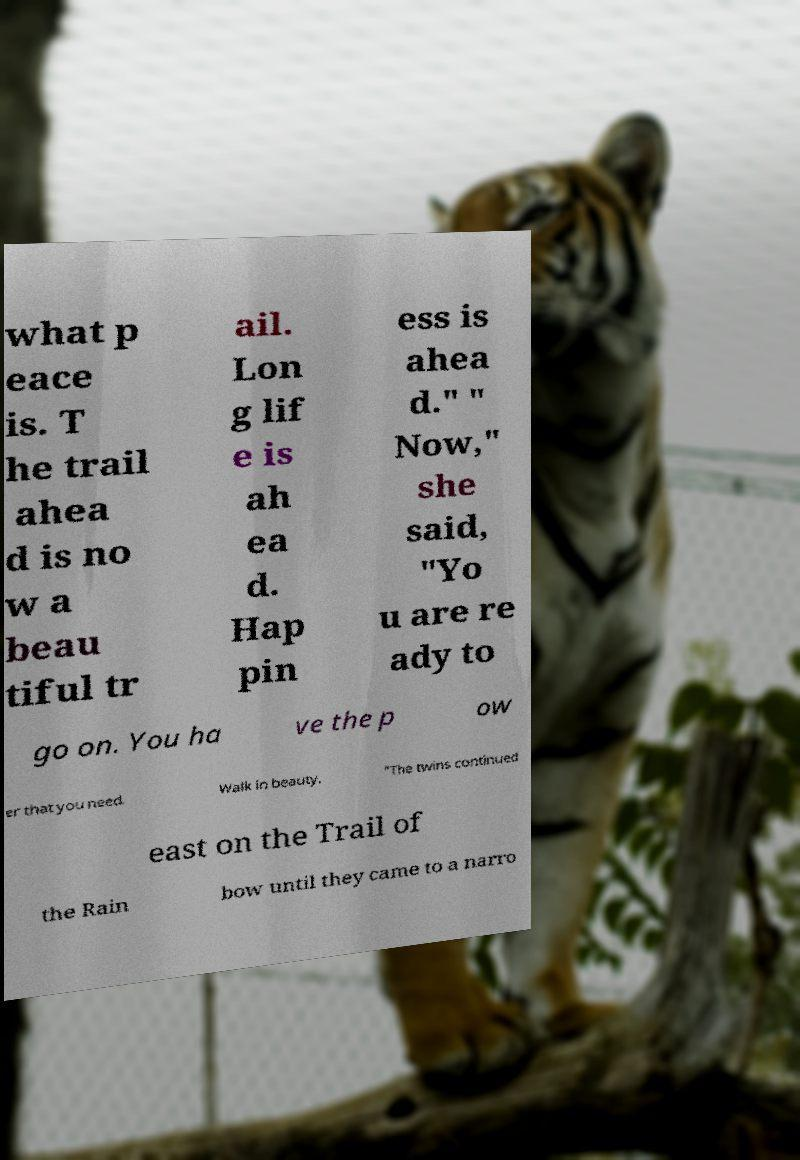Could you assist in decoding the text presented in this image and type it out clearly? what p eace is. T he trail ahea d is no w a beau tiful tr ail. Lon g lif e is ah ea d. Hap pin ess is ahea d." " Now," she said, "Yo u are re ady to go on. You ha ve the p ow er that you need. Walk in beauty. "The twins continued east on the Trail of the Rain bow until they came to a narro 